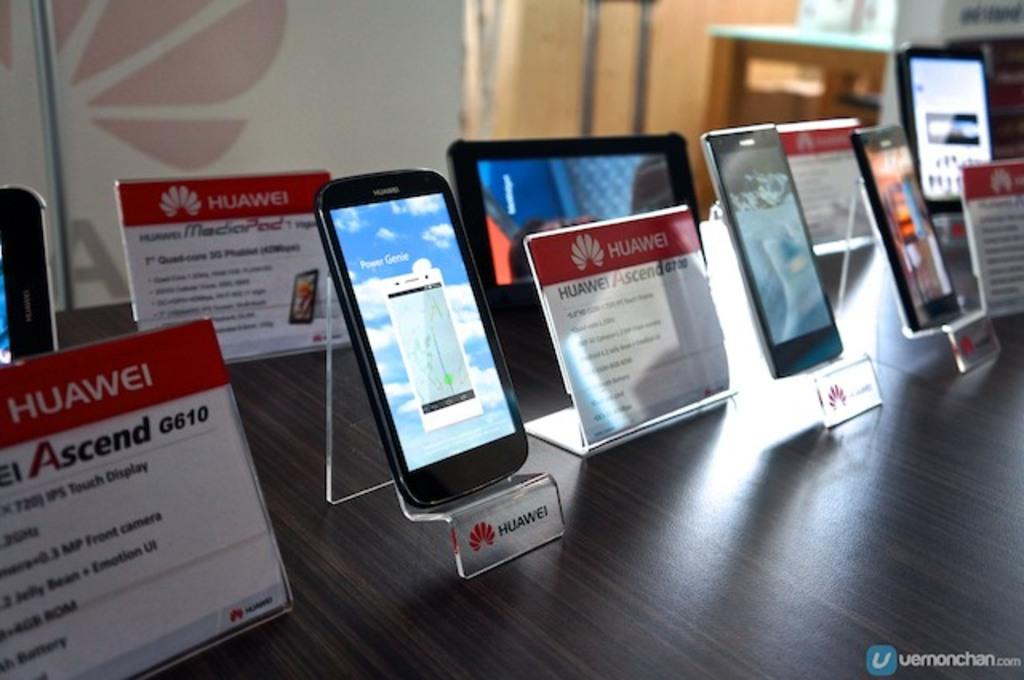Provide a one-sentence caption for the provided image. A display of many Huawei phones and tablets. 